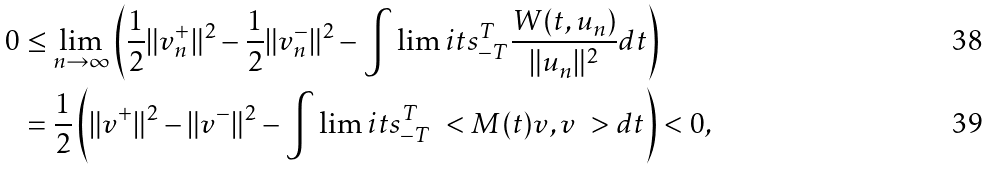<formula> <loc_0><loc_0><loc_500><loc_500>0 & \leq \lim _ { n \rightarrow \infty } \left ( \frac { 1 } { 2 } \| v _ { n } ^ { + } \| ^ { 2 } - \frac { 1 } { 2 } \| v _ { n } ^ { - } \| ^ { 2 } - \int \lim i t s _ { - T } ^ { T } \frac { W ( t , u _ { n } ) } { \| u _ { n } \| ^ { 2 } } d t \right ) \\ & = \frac { 1 } { 2 } \left ( \| v ^ { + } \| ^ { 2 } - \| v ^ { - } \| ^ { 2 } - \int \lim i t s _ { - T } ^ { T } \ < M ( t ) v , v \ > d t \right ) < 0 ,</formula> 